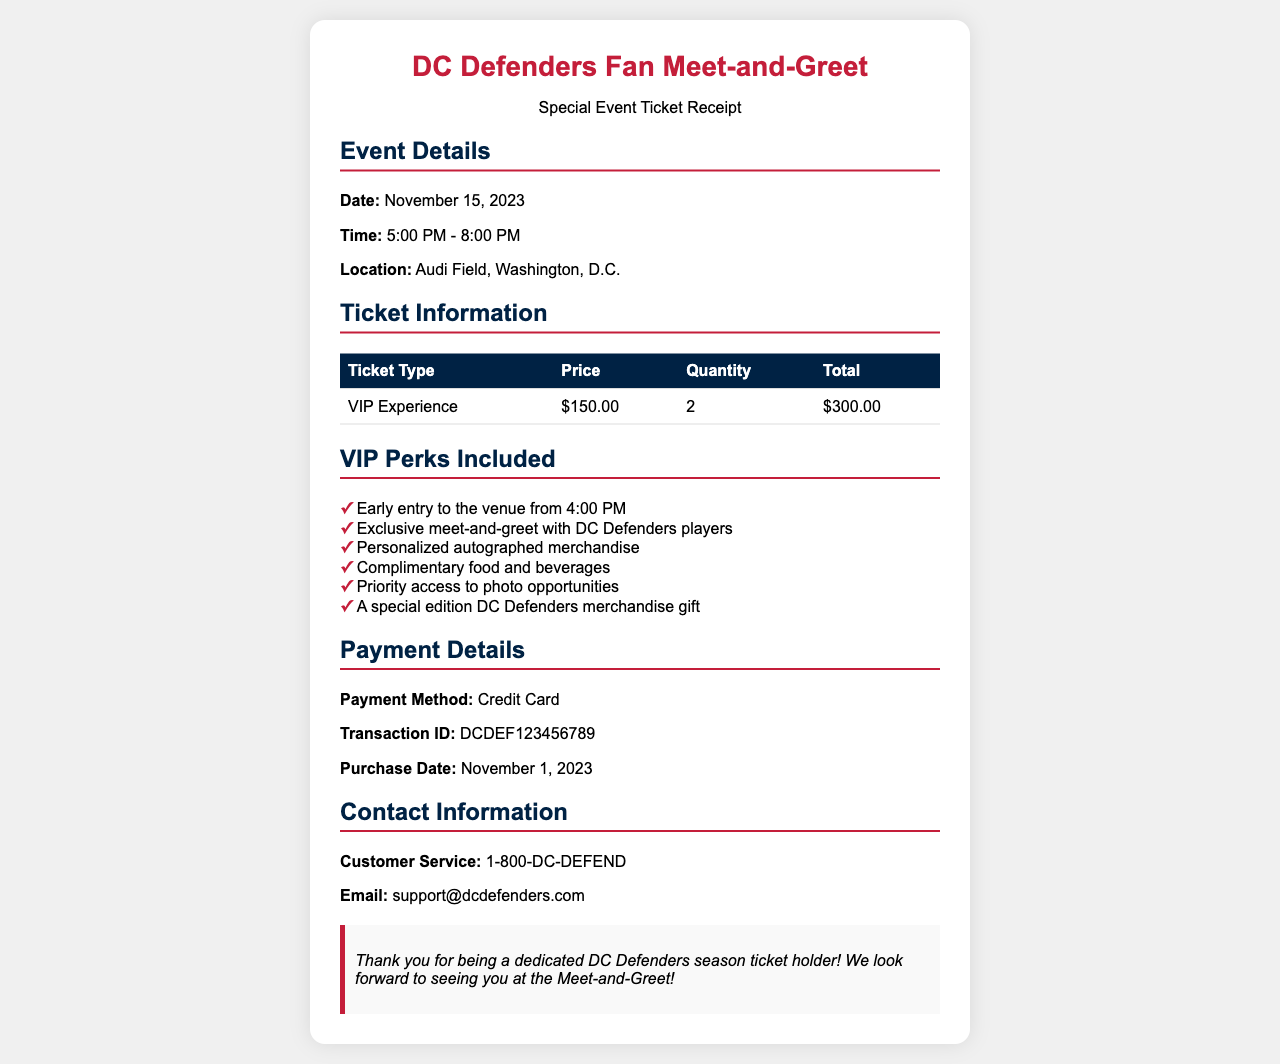What is the date of the event? The date of the event is provided in the event details section of the document.
Answer: November 15, 2023 What is the ticket type purchased? The ticket type is listed under the ticket information section of the document.
Answer: VIP Experience How many tickets were purchased? The quantity of tickets is found in the ticket information section of the document.
Answer: 2 What is the total cost of the tickets? The total cost is calculated and mentioned in the ticket information section.
Answer: $300.00 What are the VIP perks included? The VIP perks are detailed in the separate perks section of the document.
Answer: Early entry to the venue from 4:00 PM What time does the event start? The start time of the event is listed in the event details section of the document.
Answer: 5:00 PM What method of payment was used? The payment method is specified in the payment details section of the document.
Answer: Credit Card When was the purchase date? The purchase date is mentioned in the payment details section of the document.
Answer: November 1, 2023 What is the customer service contact number? The customer service number is provided in the contact information section of the document.
Answer: 1-800-DC-DEFEND 